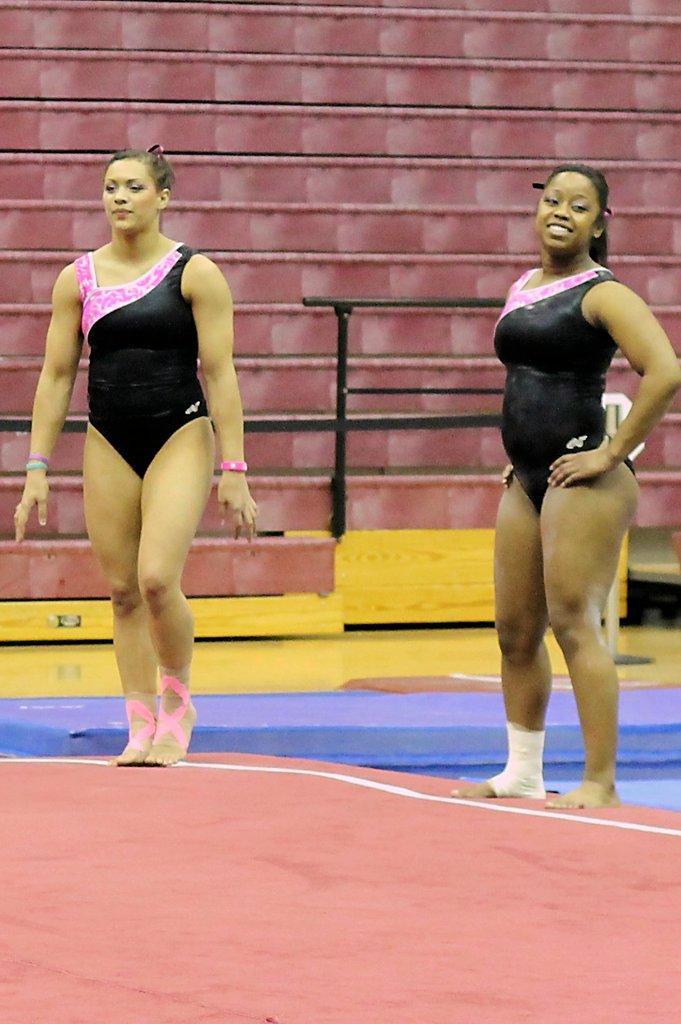Could you give a brief overview of what you see in this image? In this picture there are two wearing black color top is doing a gymnastic. Behind there is a red color frame. 